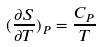<formula> <loc_0><loc_0><loc_500><loc_500>( \frac { \partial S } { \partial T } ) _ { P } = \frac { C _ { P } } { T }</formula> 